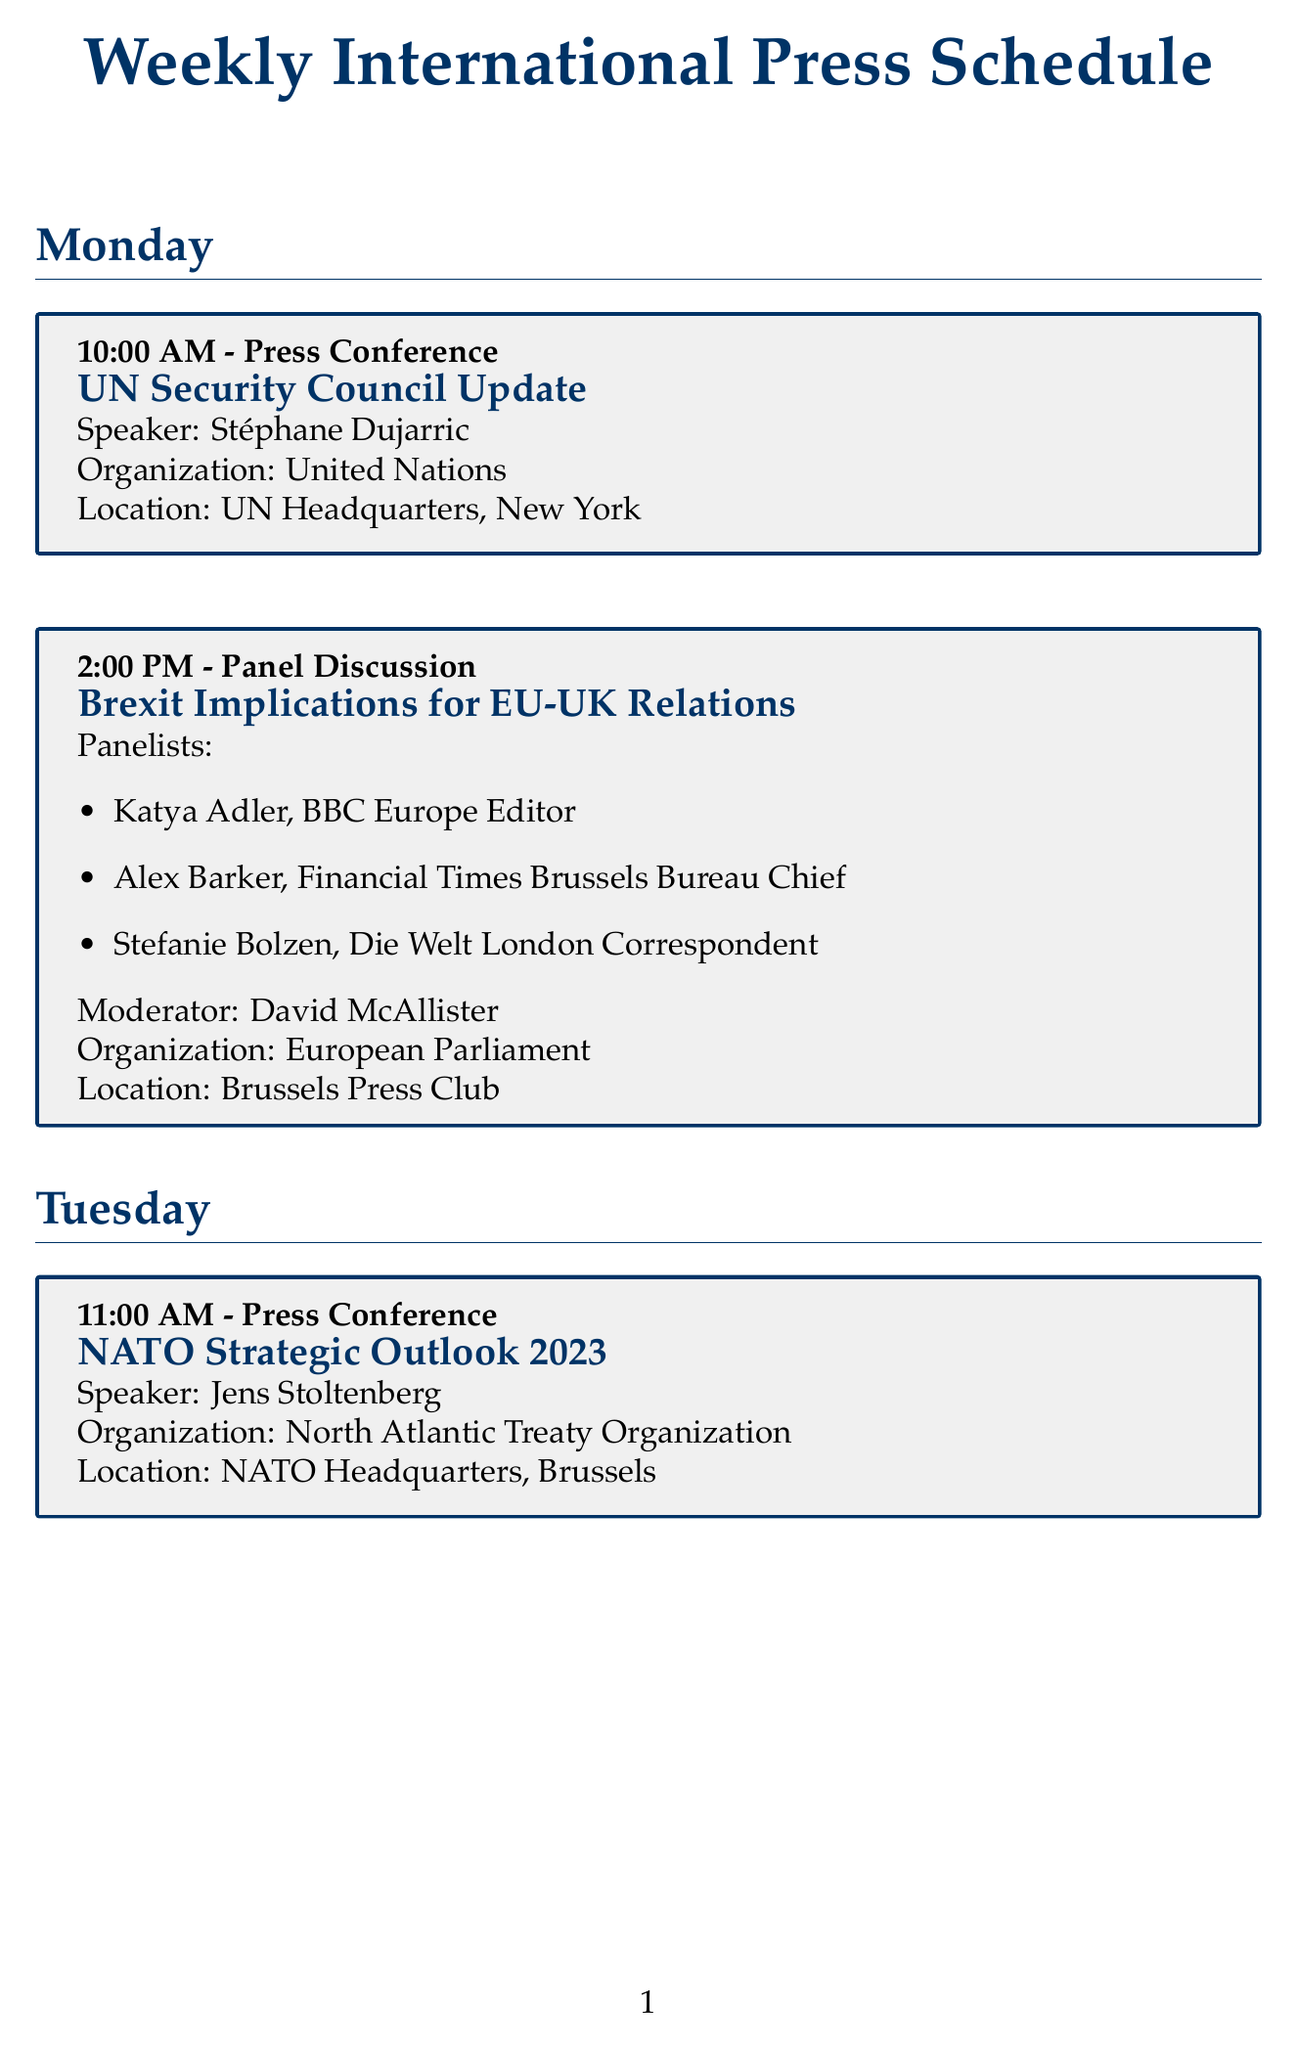What is the title of the Tuesday press conference? The title of the Tuesday press conference is explicitly stated in the schedule as "NATO Strategic Outlook 2023".
Answer: NATO Strategic Outlook 2023 Who is the moderator for the panel discussion on Climate Change? The moderator for the panel discussion on Climate Change is listed in the document as Patricia Espinosa.
Answer: Patricia Espinosa What day of the week features the press conference on WHO Global Health Update? The document specifies that the press conference on WHO Global Health Update is scheduled for Thursday.
Answer: Thursday Which organization is hosting the event on Brexit Implications for EU-UK Relations? The hosting organization for the Brexit panel discussion is clearly indicated as the European Parliament.
Answer: European Parliament How many panelists are listed for the Middle East Peace Process discussion? The document enumerates the panelists for the Middle East Peace Process discussion, which totals three individuals.
Answer: Three What is the location of the G20 Finance Ministers Meeting Outcomes press conference? The location for the G20 Finance Ministers Meeting Outcomes press conference is clearly designated as "IMF Headquarters, Washington D.C."
Answer: IMF Headquarters, Washington D.C What time is the US-China Relations panel discussion set to begin? The schedule marks the beginning time for the US-China Relations panel discussion at 1:00 PM.
Answer: 1:00 PM Who is the speaker at the UN Security Council Update press conference? The speaker for the UN Security Council Update is named in the document as Stéphane Dujarric.
Answer: Stéphane Dujarric 